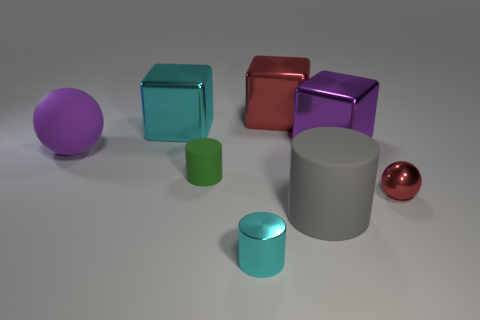Subtract all tiny cylinders. How many cylinders are left? 1 Subtract all green cylinders. How many cylinders are left? 2 Add 2 metallic cubes. How many objects exist? 10 Subtract 2 cylinders. How many cylinders are left? 1 Add 2 small green cylinders. How many small green cylinders exist? 3 Subtract 0 brown balls. How many objects are left? 8 Subtract all blocks. How many objects are left? 5 Subtract all brown blocks. Subtract all cyan balls. How many blocks are left? 3 Subtract all green cylinders. How many purple cubes are left? 1 Subtract all big gray cylinders. Subtract all large gray rubber objects. How many objects are left? 6 